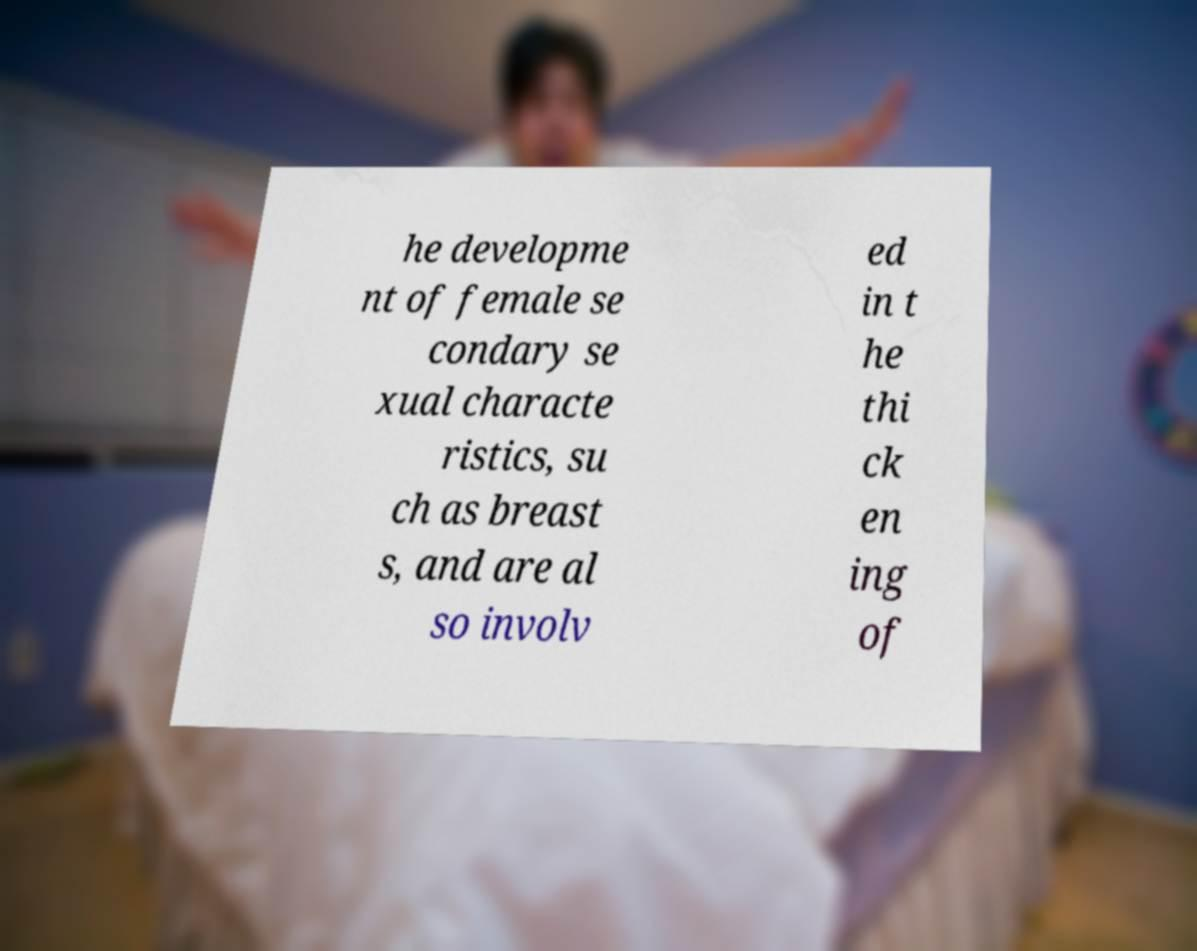Could you assist in decoding the text presented in this image and type it out clearly? he developme nt of female se condary se xual characte ristics, su ch as breast s, and are al so involv ed in t he thi ck en ing of 